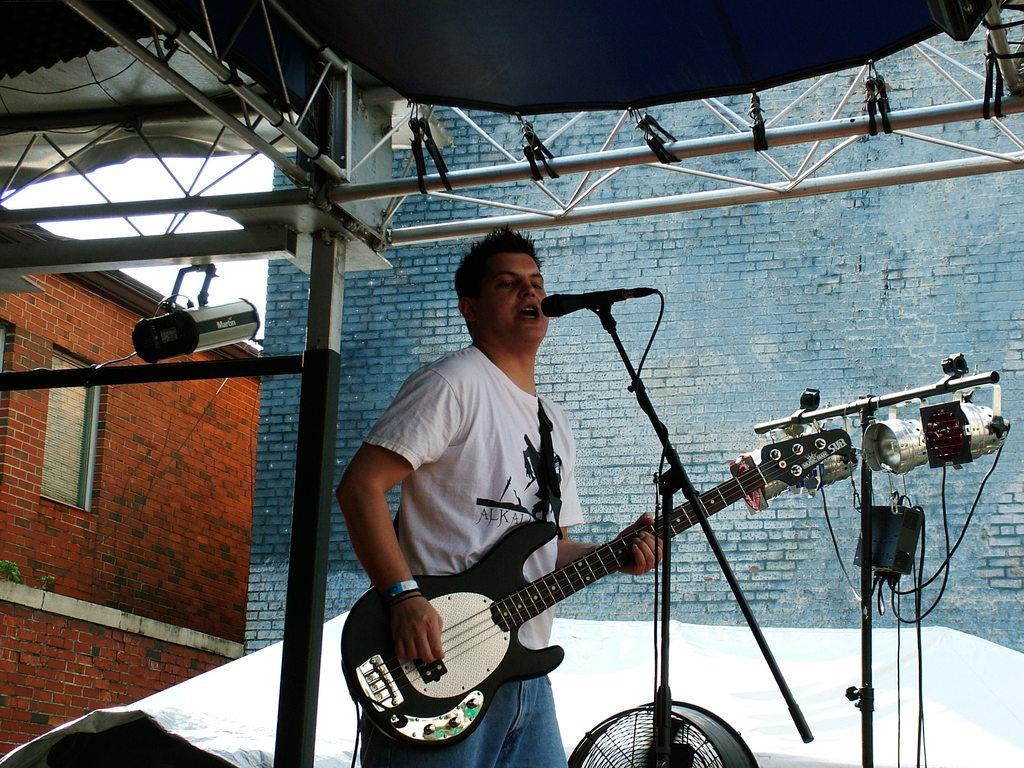Can you describe this image briefly? In this picture this person standing and holding guitar and singing. There is a microphone with stand. On the background we can see wall. This is rod. This is cable. This is window. 